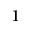<formula> <loc_0><loc_0><loc_500><loc_500>^ { 1 }</formula> 